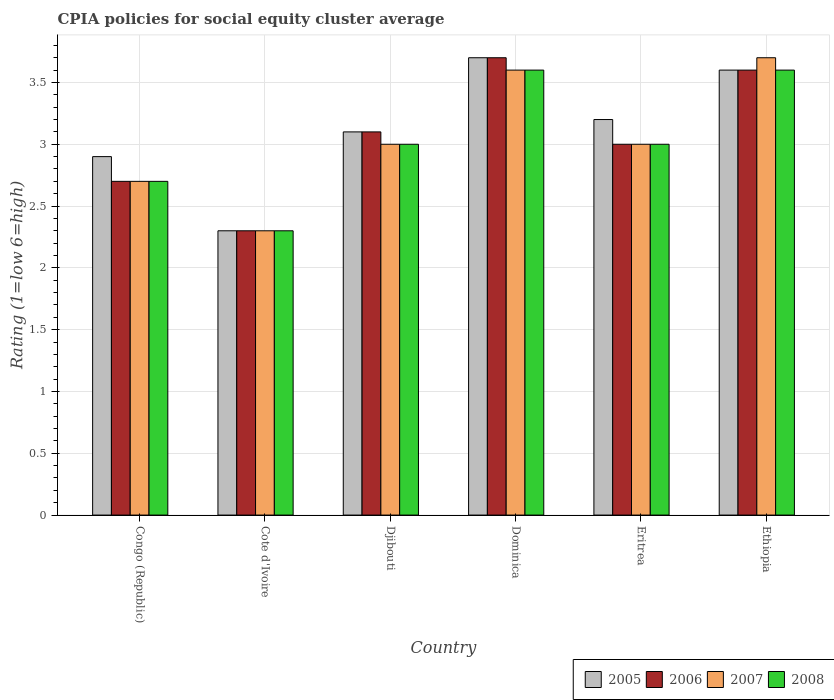Are the number of bars per tick equal to the number of legend labels?
Offer a terse response. Yes. Are the number of bars on each tick of the X-axis equal?
Your response must be concise. Yes. How many bars are there on the 1st tick from the left?
Your response must be concise. 4. What is the label of the 2nd group of bars from the left?
Provide a succinct answer. Cote d'Ivoire. In how many cases, is the number of bars for a given country not equal to the number of legend labels?
Offer a very short reply. 0. Across all countries, what is the maximum CPIA rating in 2006?
Provide a succinct answer. 3.7. In which country was the CPIA rating in 2006 maximum?
Ensure brevity in your answer.  Dominica. In which country was the CPIA rating in 2005 minimum?
Make the answer very short. Cote d'Ivoire. What is the difference between the CPIA rating in 2005 in Cote d'Ivoire and that in Ethiopia?
Provide a succinct answer. -1.3. What is the difference between the CPIA rating in 2008 in Cote d'Ivoire and the CPIA rating in 2005 in Djibouti?
Your answer should be compact. -0.8. What is the average CPIA rating in 2006 per country?
Your answer should be very brief. 3.07. What is the difference between the CPIA rating of/in 2007 and CPIA rating of/in 2008 in Ethiopia?
Your answer should be compact. 0.1. What is the ratio of the CPIA rating in 2008 in Eritrea to that in Ethiopia?
Provide a succinct answer. 0.83. Is the CPIA rating in 2008 in Djibouti less than that in Eritrea?
Your answer should be compact. No. What is the difference between the highest and the second highest CPIA rating in 2007?
Your response must be concise. 0.6. What is the difference between the highest and the lowest CPIA rating in 2008?
Give a very brief answer. 1.3. In how many countries, is the CPIA rating in 2007 greater than the average CPIA rating in 2007 taken over all countries?
Provide a succinct answer. 2. Is the sum of the CPIA rating in 2006 in Congo (Republic) and Cote d'Ivoire greater than the maximum CPIA rating in 2005 across all countries?
Provide a succinct answer. Yes. What does the 4th bar from the right in Ethiopia represents?
Give a very brief answer. 2005. Is it the case that in every country, the sum of the CPIA rating in 2007 and CPIA rating in 2008 is greater than the CPIA rating in 2005?
Ensure brevity in your answer.  Yes. How many bars are there?
Keep it short and to the point. 24. How many countries are there in the graph?
Offer a terse response. 6. Does the graph contain any zero values?
Your response must be concise. No. Does the graph contain grids?
Ensure brevity in your answer.  Yes. Where does the legend appear in the graph?
Provide a succinct answer. Bottom right. How many legend labels are there?
Your answer should be very brief. 4. How are the legend labels stacked?
Ensure brevity in your answer.  Horizontal. What is the title of the graph?
Your answer should be very brief. CPIA policies for social equity cluster average. What is the Rating (1=low 6=high) in 2005 in Congo (Republic)?
Ensure brevity in your answer.  2.9. What is the Rating (1=low 6=high) of 2006 in Congo (Republic)?
Provide a succinct answer. 2.7. What is the Rating (1=low 6=high) in 2007 in Congo (Republic)?
Your response must be concise. 2.7. What is the Rating (1=low 6=high) of 2005 in Cote d'Ivoire?
Provide a short and direct response. 2.3. What is the Rating (1=low 6=high) in 2006 in Djibouti?
Your answer should be compact. 3.1. What is the Rating (1=low 6=high) of 2007 in Djibouti?
Your answer should be compact. 3. What is the Rating (1=low 6=high) in 2008 in Djibouti?
Offer a terse response. 3. What is the Rating (1=low 6=high) of 2005 in Dominica?
Ensure brevity in your answer.  3.7. What is the Rating (1=low 6=high) in 2006 in Dominica?
Provide a succinct answer. 3.7. What is the Rating (1=low 6=high) of 2008 in Dominica?
Provide a succinct answer. 3.6. What is the Rating (1=low 6=high) of 2005 in Eritrea?
Ensure brevity in your answer.  3.2. What is the Rating (1=low 6=high) in 2006 in Eritrea?
Your answer should be compact. 3. What is the Rating (1=low 6=high) in 2005 in Ethiopia?
Make the answer very short. 3.6. What is the Rating (1=low 6=high) of 2006 in Ethiopia?
Ensure brevity in your answer.  3.6. What is the Rating (1=low 6=high) of 2008 in Ethiopia?
Keep it short and to the point. 3.6. Across all countries, what is the maximum Rating (1=low 6=high) in 2007?
Offer a terse response. 3.7. Across all countries, what is the maximum Rating (1=low 6=high) of 2008?
Offer a terse response. 3.6. Across all countries, what is the minimum Rating (1=low 6=high) of 2006?
Give a very brief answer. 2.3. Across all countries, what is the minimum Rating (1=low 6=high) of 2007?
Your answer should be very brief. 2.3. What is the total Rating (1=low 6=high) in 2005 in the graph?
Make the answer very short. 18.8. What is the total Rating (1=low 6=high) of 2006 in the graph?
Offer a very short reply. 18.4. What is the total Rating (1=low 6=high) of 2008 in the graph?
Offer a terse response. 18.2. What is the difference between the Rating (1=low 6=high) of 2005 in Congo (Republic) and that in Cote d'Ivoire?
Make the answer very short. 0.6. What is the difference between the Rating (1=low 6=high) in 2008 in Congo (Republic) and that in Cote d'Ivoire?
Offer a very short reply. 0.4. What is the difference between the Rating (1=low 6=high) of 2006 in Congo (Republic) and that in Djibouti?
Provide a short and direct response. -0.4. What is the difference between the Rating (1=low 6=high) of 2007 in Congo (Republic) and that in Djibouti?
Ensure brevity in your answer.  -0.3. What is the difference between the Rating (1=low 6=high) of 2005 in Congo (Republic) and that in Dominica?
Offer a terse response. -0.8. What is the difference between the Rating (1=low 6=high) of 2007 in Congo (Republic) and that in Dominica?
Your response must be concise. -0.9. What is the difference between the Rating (1=low 6=high) in 2005 in Congo (Republic) and that in Eritrea?
Your answer should be very brief. -0.3. What is the difference between the Rating (1=low 6=high) of 2006 in Congo (Republic) and that in Eritrea?
Provide a succinct answer. -0.3. What is the difference between the Rating (1=low 6=high) in 2008 in Congo (Republic) and that in Eritrea?
Make the answer very short. -0.3. What is the difference between the Rating (1=low 6=high) of 2007 in Congo (Republic) and that in Ethiopia?
Provide a short and direct response. -1. What is the difference between the Rating (1=low 6=high) in 2008 in Congo (Republic) and that in Ethiopia?
Your answer should be very brief. -0.9. What is the difference between the Rating (1=low 6=high) in 2005 in Cote d'Ivoire and that in Djibouti?
Offer a terse response. -0.8. What is the difference between the Rating (1=low 6=high) of 2007 in Cote d'Ivoire and that in Djibouti?
Make the answer very short. -0.7. What is the difference between the Rating (1=low 6=high) in 2005 in Cote d'Ivoire and that in Dominica?
Ensure brevity in your answer.  -1.4. What is the difference between the Rating (1=low 6=high) of 2006 in Cote d'Ivoire and that in Dominica?
Provide a succinct answer. -1.4. What is the difference between the Rating (1=low 6=high) in 2007 in Cote d'Ivoire and that in Dominica?
Your answer should be very brief. -1.3. What is the difference between the Rating (1=low 6=high) of 2006 in Cote d'Ivoire and that in Eritrea?
Your answer should be compact. -0.7. What is the difference between the Rating (1=low 6=high) in 2007 in Cote d'Ivoire and that in Eritrea?
Provide a short and direct response. -0.7. What is the difference between the Rating (1=low 6=high) in 2005 in Cote d'Ivoire and that in Ethiopia?
Ensure brevity in your answer.  -1.3. What is the difference between the Rating (1=low 6=high) in 2006 in Cote d'Ivoire and that in Ethiopia?
Offer a very short reply. -1.3. What is the difference between the Rating (1=low 6=high) in 2006 in Djibouti and that in Dominica?
Provide a short and direct response. -0.6. What is the difference between the Rating (1=low 6=high) in 2008 in Djibouti and that in Dominica?
Your answer should be very brief. -0.6. What is the difference between the Rating (1=low 6=high) of 2005 in Djibouti and that in Eritrea?
Keep it short and to the point. -0.1. What is the difference between the Rating (1=low 6=high) in 2006 in Djibouti and that in Eritrea?
Give a very brief answer. 0.1. What is the difference between the Rating (1=low 6=high) in 2008 in Djibouti and that in Eritrea?
Give a very brief answer. 0. What is the difference between the Rating (1=low 6=high) of 2005 in Djibouti and that in Ethiopia?
Provide a succinct answer. -0.5. What is the difference between the Rating (1=low 6=high) of 2006 in Djibouti and that in Ethiopia?
Provide a succinct answer. -0.5. What is the difference between the Rating (1=low 6=high) in 2007 in Djibouti and that in Ethiopia?
Offer a terse response. -0.7. What is the difference between the Rating (1=low 6=high) in 2005 in Dominica and that in Eritrea?
Provide a succinct answer. 0.5. What is the difference between the Rating (1=low 6=high) in 2006 in Dominica and that in Eritrea?
Your answer should be very brief. 0.7. What is the difference between the Rating (1=low 6=high) in 2007 in Dominica and that in Ethiopia?
Offer a very short reply. -0.1. What is the difference between the Rating (1=low 6=high) of 2006 in Eritrea and that in Ethiopia?
Your answer should be very brief. -0.6. What is the difference between the Rating (1=low 6=high) in 2008 in Eritrea and that in Ethiopia?
Your response must be concise. -0.6. What is the difference between the Rating (1=low 6=high) of 2005 in Congo (Republic) and the Rating (1=low 6=high) of 2006 in Cote d'Ivoire?
Your answer should be very brief. 0.6. What is the difference between the Rating (1=low 6=high) of 2005 in Congo (Republic) and the Rating (1=low 6=high) of 2007 in Cote d'Ivoire?
Provide a short and direct response. 0.6. What is the difference between the Rating (1=low 6=high) in 2007 in Congo (Republic) and the Rating (1=low 6=high) in 2008 in Cote d'Ivoire?
Keep it short and to the point. 0.4. What is the difference between the Rating (1=low 6=high) of 2005 in Congo (Republic) and the Rating (1=low 6=high) of 2007 in Djibouti?
Ensure brevity in your answer.  -0.1. What is the difference between the Rating (1=low 6=high) in 2005 in Congo (Republic) and the Rating (1=low 6=high) in 2008 in Djibouti?
Keep it short and to the point. -0.1. What is the difference between the Rating (1=low 6=high) of 2006 in Congo (Republic) and the Rating (1=low 6=high) of 2008 in Djibouti?
Offer a very short reply. -0.3. What is the difference between the Rating (1=low 6=high) of 2007 in Congo (Republic) and the Rating (1=low 6=high) of 2008 in Djibouti?
Give a very brief answer. -0.3. What is the difference between the Rating (1=low 6=high) of 2005 in Congo (Republic) and the Rating (1=low 6=high) of 2008 in Dominica?
Give a very brief answer. -0.7. What is the difference between the Rating (1=low 6=high) of 2005 in Congo (Republic) and the Rating (1=low 6=high) of 2006 in Eritrea?
Your answer should be very brief. -0.1. What is the difference between the Rating (1=low 6=high) in 2006 in Congo (Republic) and the Rating (1=low 6=high) in 2007 in Eritrea?
Keep it short and to the point. -0.3. What is the difference between the Rating (1=low 6=high) in 2006 in Congo (Republic) and the Rating (1=low 6=high) in 2008 in Eritrea?
Provide a short and direct response. -0.3. What is the difference between the Rating (1=low 6=high) of 2007 in Congo (Republic) and the Rating (1=low 6=high) of 2008 in Eritrea?
Give a very brief answer. -0.3. What is the difference between the Rating (1=low 6=high) in 2005 in Congo (Republic) and the Rating (1=low 6=high) in 2006 in Ethiopia?
Your answer should be compact. -0.7. What is the difference between the Rating (1=low 6=high) of 2006 in Congo (Republic) and the Rating (1=low 6=high) of 2007 in Ethiopia?
Offer a very short reply. -1. What is the difference between the Rating (1=low 6=high) in 2007 in Congo (Republic) and the Rating (1=low 6=high) in 2008 in Ethiopia?
Keep it short and to the point. -0.9. What is the difference between the Rating (1=low 6=high) in 2005 in Cote d'Ivoire and the Rating (1=low 6=high) in 2006 in Djibouti?
Give a very brief answer. -0.8. What is the difference between the Rating (1=low 6=high) in 2005 in Cote d'Ivoire and the Rating (1=low 6=high) in 2008 in Djibouti?
Make the answer very short. -0.7. What is the difference between the Rating (1=low 6=high) in 2006 in Cote d'Ivoire and the Rating (1=low 6=high) in 2007 in Djibouti?
Provide a succinct answer. -0.7. What is the difference between the Rating (1=low 6=high) of 2007 in Cote d'Ivoire and the Rating (1=low 6=high) of 2008 in Djibouti?
Your response must be concise. -0.7. What is the difference between the Rating (1=low 6=high) in 2005 in Cote d'Ivoire and the Rating (1=low 6=high) in 2006 in Dominica?
Your answer should be very brief. -1.4. What is the difference between the Rating (1=low 6=high) in 2005 in Cote d'Ivoire and the Rating (1=low 6=high) in 2007 in Dominica?
Ensure brevity in your answer.  -1.3. What is the difference between the Rating (1=low 6=high) in 2005 in Cote d'Ivoire and the Rating (1=low 6=high) in 2008 in Dominica?
Offer a terse response. -1.3. What is the difference between the Rating (1=low 6=high) of 2006 in Cote d'Ivoire and the Rating (1=low 6=high) of 2007 in Dominica?
Make the answer very short. -1.3. What is the difference between the Rating (1=low 6=high) of 2006 in Cote d'Ivoire and the Rating (1=low 6=high) of 2008 in Dominica?
Give a very brief answer. -1.3. What is the difference between the Rating (1=low 6=high) of 2005 in Cote d'Ivoire and the Rating (1=low 6=high) of 2006 in Eritrea?
Make the answer very short. -0.7. What is the difference between the Rating (1=low 6=high) of 2005 in Cote d'Ivoire and the Rating (1=low 6=high) of 2007 in Eritrea?
Provide a short and direct response. -0.7. What is the difference between the Rating (1=low 6=high) in 2006 in Cote d'Ivoire and the Rating (1=low 6=high) in 2007 in Eritrea?
Provide a succinct answer. -0.7. What is the difference between the Rating (1=low 6=high) of 2005 in Cote d'Ivoire and the Rating (1=low 6=high) of 2006 in Ethiopia?
Your answer should be compact. -1.3. What is the difference between the Rating (1=low 6=high) in 2005 in Cote d'Ivoire and the Rating (1=low 6=high) in 2007 in Ethiopia?
Provide a short and direct response. -1.4. What is the difference between the Rating (1=low 6=high) in 2006 in Cote d'Ivoire and the Rating (1=low 6=high) in 2007 in Ethiopia?
Provide a succinct answer. -1.4. What is the difference between the Rating (1=low 6=high) in 2006 in Cote d'Ivoire and the Rating (1=low 6=high) in 2008 in Ethiopia?
Your answer should be very brief. -1.3. What is the difference between the Rating (1=low 6=high) in 2007 in Cote d'Ivoire and the Rating (1=low 6=high) in 2008 in Ethiopia?
Provide a succinct answer. -1.3. What is the difference between the Rating (1=low 6=high) in 2006 in Djibouti and the Rating (1=low 6=high) in 2008 in Dominica?
Keep it short and to the point. -0.5. What is the difference between the Rating (1=low 6=high) in 2005 in Djibouti and the Rating (1=low 6=high) in 2006 in Eritrea?
Offer a terse response. 0.1. What is the difference between the Rating (1=low 6=high) of 2005 in Djibouti and the Rating (1=low 6=high) of 2007 in Eritrea?
Offer a terse response. 0.1. What is the difference between the Rating (1=low 6=high) of 2006 in Djibouti and the Rating (1=low 6=high) of 2007 in Eritrea?
Offer a terse response. 0.1. What is the difference between the Rating (1=low 6=high) of 2006 in Djibouti and the Rating (1=low 6=high) of 2008 in Eritrea?
Your answer should be very brief. 0.1. What is the difference between the Rating (1=low 6=high) in 2005 in Djibouti and the Rating (1=low 6=high) in 2006 in Ethiopia?
Ensure brevity in your answer.  -0.5. What is the difference between the Rating (1=low 6=high) in 2005 in Djibouti and the Rating (1=low 6=high) in 2007 in Ethiopia?
Give a very brief answer. -0.6. What is the difference between the Rating (1=low 6=high) in 2005 in Djibouti and the Rating (1=low 6=high) in 2008 in Ethiopia?
Your answer should be compact. -0.5. What is the difference between the Rating (1=low 6=high) in 2006 in Djibouti and the Rating (1=low 6=high) in 2007 in Ethiopia?
Your answer should be compact. -0.6. What is the difference between the Rating (1=low 6=high) in 2006 in Djibouti and the Rating (1=low 6=high) in 2008 in Ethiopia?
Give a very brief answer. -0.5. What is the difference between the Rating (1=low 6=high) in 2005 in Dominica and the Rating (1=low 6=high) in 2006 in Eritrea?
Keep it short and to the point. 0.7. What is the difference between the Rating (1=low 6=high) of 2005 in Dominica and the Rating (1=low 6=high) of 2008 in Eritrea?
Offer a very short reply. 0.7. What is the difference between the Rating (1=low 6=high) of 2006 in Dominica and the Rating (1=low 6=high) of 2007 in Eritrea?
Your answer should be compact. 0.7. What is the difference between the Rating (1=low 6=high) in 2007 in Dominica and the Rating (1=low 6=high) in 2008 in Eritrea?
Provide a succinct answer. 0.6. What is the difference between the Rating (1=low 6=high) in 2005 in Dominica and the Rating (1=low 6=high) in 2006 in Ethiopia?
Make the answer very short. 0.1. What is the difference between the Rating (1=low 6=high) of 2005 in Dominica and the Rating (1=low 6=high) of 2007 in Ethiopia?
Give a very brief answer. 0. What is the difference between the Rating (1=low 6=high) in 2006 in Dominica and the Rating (1=low 6=high) in 2007 in Ethiopia?
Provide a succinct answer. 0. What is the difference between the Rating (1=low 6=high) in 2006 in Dominica and the Rating (1=low 6=high) in 2008 in Ethiopia?
Offer a terse response. 0.1. What is the difference between the Rating (1=low 6=high) of 2007 in Dominica and the Rating (1=low 6=high) of 2008 in Ethiopia?
Provide a succinct answer. 0. What is the difference between the Rating (1=low 6=high) of 2006 in Eritrea and the Rating (1=low 6=high) of 2007 in Ethiopia?
Your answer should be very brief. -0.7. What is the difference between the Rating (1=low 6=high) of 2006 in Eritrea and the Rating (1=low 6=high) of 2008 in Ethiopia?
Your answer should be compact. -0.6. What is the average Rating (1=low 6=high) of 2005 per country?
Offer a terse response. 3.13. What is the average Rating (1=low 6=high) of 2006 per country?
Your answer should be compact. 3.07. What is the average Rating (1=low 6=high) of 2007 per country?
Give a very brief answer. 3.05. What is the average Rating (1=low 6=high) of 2008 per country?
Your response must be concise. 3.03. What is the difference between the Rating (1=low 6=high) in 2005 and Rating (1=low 6=high) in 2006 in Congo (Republic)?
Your answer should be compact. 0.2. What is the difference between the Rating (1=low 6=high) in 2005 and Rating (1=low 6=high) in 2007 in Congo (Republic)?
Provide a short and direct response. 0.2. What is the difference between the Rating (1=low 6=high) in 2005 and Rating (1=low 6=high) in 2008 in Congo (Republic)?
Your answer should be very brief. 0.2. What is the difference between the Rating (1=low 6=high) of 2006 and Rating (1=low 6=high) of 2007 in Congo (Republic)?
Keep it short and to the point. 0. What is the difference between the Rating (1=low 6=high) in 2005 and Rating (1=low 6=high) in 2006 in Cote d'Ivoire?
Keep it short and to the point. 0. What is the difference between the Rating (1=low 6=high) in 2005 and Rating (1=low 6=high) in 2008 in Cote d'Ivoire?
Provide a short and direct response. 0. What is the difference between the Rating (1=low 6=high) of 2006 and Rating (1=low 6=high) of 2007 in Cote d'Ivoire?
Ensure brevity in your answer.  0. What is the difference between the Rating (1=low 6=high) of 2006 and Rating (1=low 6=high) of 2008 in Cote d'Ivoire?
Offer a very short reply. 0. What is the difference between the Rating (1=low 6=high) in 2007 and Rating (1=low 6=high) in 2008 in Cote d'Ivoire?
Give a very brief answer. 0. What is the difference between the Rating (1=low 6=high) in 2005 and Rating (1=low 6=high) in 2006 in Djibouti?
Your answer should be compact. 0. What is the difference between the Rating (1=low 6=high) of 2005 and Rating (1=low 6=high) of 2006 in Dominica?
Your response must be concise. 0. What is the difference between the Rating (1=low 6=high) in 2005 and Rating (1=low 6=high) in 2007 in Dominica?
Give a very brief answer. 0.1. What is the difference between the Rating (1=low 6=high) in 2005 and Rating (1=low 6=high) in 2008 in Dominica?
Keep it short and to the point. 0.1. What is the difference between the Rating (1=low 6=high) of 2006 and Rating (1=low 6=high) of 2007 in Dominica?
Your answer should be compact. 0.1. What is the difference between the Rating (1=low 6=high) in 2006 and Rating (1=low 6=high) in 2008 in Dominica?
Offer a terse response. 0.1. What is the difference between the Rating (1=low 6=high) in 2005 and Rating (1=low 6=high) in 2006 in Eritrea?
Ensure brevity in your answer.  0.2. What is the difference between the Rating (1=low 6=high) in 2006 and Rating (1=low 6=high) in 2008 in Eritrea?
Provide a short and direct response. 0. What is the difference between the Rating (1=low 6=high) in 2005 and Rating (1=low 6=high) in 2006 in Ethiopia?
Provide a short and direct response. 0. What is the difference between the Rating (1=low 6=high) of 2005 and Rating (1=low 6=high) of 2008 in Ethiopia?
Provide a succinct answer. 0. What is the difference between the Rating (1=low 6=high) of 2006 and Rating (1=low 6=high) of 2007 in Ethiopia?
Give a very brief answer. -0.1. What is the ratio of the Rating (1=low 6=high) of 2005 in Congo (Republic) to that in Cote d'Ivoire?
Your answer should be compact. 1.26. What is the ratio of the Rating (1=low 6=high) in 2006 in Congo (Republic) to that in Cote d'Ivoire?
Make the answer very short. 1.17. What is the ratio of the Rating (1=low 6=high) of 2007 in Congo (Republic) to that in Cote d'Ivoire?
Ensure brevity in your answer.  1.17. What is the ratio of the Rating (1=low 6=high) in 2008 in Congo (Republic) to that in Cote d'Ivoire?
Make the answer very short. 1.17. What is the ratio of the Rating (1=low 6=high) in 2005 in Congo (Republic) to that in Djibouti?
Make the answer very short. 0.94. What is the ratio of the Rating (1=low 6=high) of 2006 in Congo (Republic) to that in Djibouti?
Offer a very short reply. 0.87. What is the ratio of the Rating (1=low 6=high) of 2007 in Congo (Republic) to that in Djibouti?
Offer a terse response. 0.9. What is the ratio of the Rating (1=low 6=high) in 2008 in Congo (Republic) to that in Djibouti?
Offer a terse response. 0.9. What is the ratio of the Rating (1=low 6=high) in 2005 in Congo (Republic) to that in Dominica?
Provide a succinct answer. 0.78. What is the ratio of the Rating (1=low 6=high) in 2006 in Congo (Republic) to that in Dominica?
Provide a succinct answer. 0.73. What is the ratio of the Rating (1=low 6=high) in 2007 in Congo (Republic) to that in Dominica?
Your response must be concise. 0.75. What is the ratio of the Rating (1=low 6=high) in 2008 in Congo (Republic) to that in Dominica?
Your answer should be very brief. 0.75. What is the ratio of the Rating (1=low 6=high) of 2005 in Congo (Republic) to that in Eritrea?
Your answer should be compact. 0.91. What is the ratio of the Rating (1=low 6=high) in 2006 in Congo (Republic) to that in Eritrea?
Give a very brief answer. 0.9. What is the ratio of the Rating (1=low 6=high) of 2005 in Congo (Republic) to that in Ethiopia?
Provide a short and direct response. 0.81. What is the ratio of the Rating (1=low 6=high) in 2006 in Congo (Republic) to that in Ethiopia?
Offer a very short reply. 0.75. What is the ratio of the Rating (1=low 6=high) in 2007 in Congo (Republic) to that in Ethiopia?
Offer a very short reply. 0.73. What is the ratio of the Rating (1=low 6=high) of 2005 in Cote d'Ivoire to that in Djibouti?
Your answer should be compact. 0.74. What is the ratio of the Rating (1=low 6=high) in 2006 in Cote d'Ivoire to that in Djibouti?
Make the answer very short. 0.74. What is the ratio of the Rating (1=low 6=high) of 2007 in Cote d'Ivoire to that in Djibouti?
Ensure brevity in your answer.  0.77. What is the ratio of the Rating (1=low 6=high) of 2008 in Cote d'Ivoire to that in Djibouti?
Provide a succinct answer. 0.77. What is the ratio of the Rating (1=low 6=high) of 2005 in Cote d'Ivoire to that in Dominica?
Give a very brief answer. 0.62. What is the ratio of the Rating (1=low 6=high) in 2006 in Cote d'Ivoire to that in Dominica?
Make the answer very short. 0.62. What is the ratio of the Rating (1=low 6=high) of 2007 in Cote d'Ivoire to that in Dominica?
Your answer should be very brief. 0.64. What is the ratio of the Rating (1=low 6=high) in 2008 in Cote d'Ivoire to that in Dominica?
Offer a terse response. 0.64. What is the ratio of the Rating (1=low 6=high) of 2005 in Cote d'Ivoire to that in Eritrea?
Your answer should be very brief. 0.72. What is the ratio of the Rating (1=low 6=high) in 2006 in Cote d'Ivoire to that in Eritrea?
Your answer should be very brief. 0.77. What is the ratio of the Rating (1=low 6=high) of 2007 in Cote d'Ivoire to that in Eritrea?
Offer a very short reply. 0.77. What is the ratio of the Rating (1=low 6=high) in 2008 in Cote d'Ivoire to that in Eritrea?
Your answer should be very brief. 0.77. What is the ratio of the Rating (1=low 6=high) in 2005 in Cote d'Ivoire to that in Ethiopia?
Give a very brief answer. 0.64. What is the ratio of the Rating (1=low 6=high) in 2006 in Cote d'Ivoire to that in Ethiopia?
Offer a very short reply. 0.64. What is the ratio of the Rating (1=low 6=high) in 2007 in Cote d'Ivoire to that in Ethiopia?
Offer a very short reply. 0.62. What is the ratio of the Rating (1=low 6=high) of 2008 in Cote d'Ivoire to that in Ethiopia?
Provide a succinct answer. 0.64. What is the ratio of the Rating (1=low 6=high) of 2005 in Djibouti to that in Dominica?
Offer a very short reply. 0.84. What is the ratio of the Rating (1=low 6=high) of 2006 in Djibouti to that in Dominica?
Keep it short and to the point. 0.84. What is the ratio of the Rating (1=low 6=high) of 2008 in Djibouti to that in Dominica?
Your answer should be compact. 0.83. What is the ratio of the Rating (1=low 6=high) in 2005 in Djibouti to that in Eritrea?
Offer a terse response. 0.97. What is the ratio of the Rating (1=low 6=high) in 2006 in Djibouti to that in Eritrea?
Offer a terse response. 1.03. What is the ratio of the Rating (1=low 6=high) of 2008 in Djibouti to that in Eritrea?
Provide a succinct answer. 1. What is the ratio of the Rating (1=low 6=high) of 2005 in Djibouti to that in Ethiopia?
Make the answer very short. 0.86. What is the ratio of the Rating (1=low 6=high) in 2006 in Djibouti to that in Ethiopia?
Your answer should be very brief. 0.86. What is the ratio of the Rating (1=low 6=high) in 2007 in Djibouti to that in Ethiopia?
Provide a short and direct response. 0.81. What is the ratio of the Rating (1=low 6=high) of 2008 in Djibouti to that in Ethiopia?
Your answer should be very brief. 0.83. What is the ratio of the Rating (1=low 6=high) in 2005 in Dominica to that in Eritrea?
Your response must be concise. 1.16. What is the ratio of the Rating (1=low 6=high) in 2006 in Dominica to that in Eritrea?
Provide a succinct answer. 1.23. What is the ratio of the Rating (1=low 6=high) in 2007 in Dominica to that in Eritrea?
Your answer should be compact. 1.2. What is the ratio of the Rating (1=low 6=high) in 2005 in Dominica to that in Ethiopia?
Make the answer very short. 1.03. What is the ratio of the Rating (1=low 6=high) of 2006 in Dominica to that in Ethiopia?
Your answer should be very brief. 1.03. What is the ratio of the Rating (1=low 6=high) in 2005 in Eritrea to that in Ethiopia?
Offer a very short reply. 0.89. What is the ratio of the Rating (1=low 6=high) of 2006 in Eritrea to that in Ethiopia?
Your response must be concise. 0.83. What is the ratio of the Rating (1=low 6=high) in 2007 in Eritrea to that in Ethiopia?
Provide a succinct answer. 0.81. What is the difference between the highest and the second highest Rating (1=low 6=high) of 2007?
Offer a terse response. 0.1. What is the difference between the highest and the second highest Rating (1=low 6=high) in 2008?
Your answer should be very brief. 0. What is the difference between the highest and the lowest Rating (1=low 6=high) in 2006?
Give a very brief answer. 1.4. 